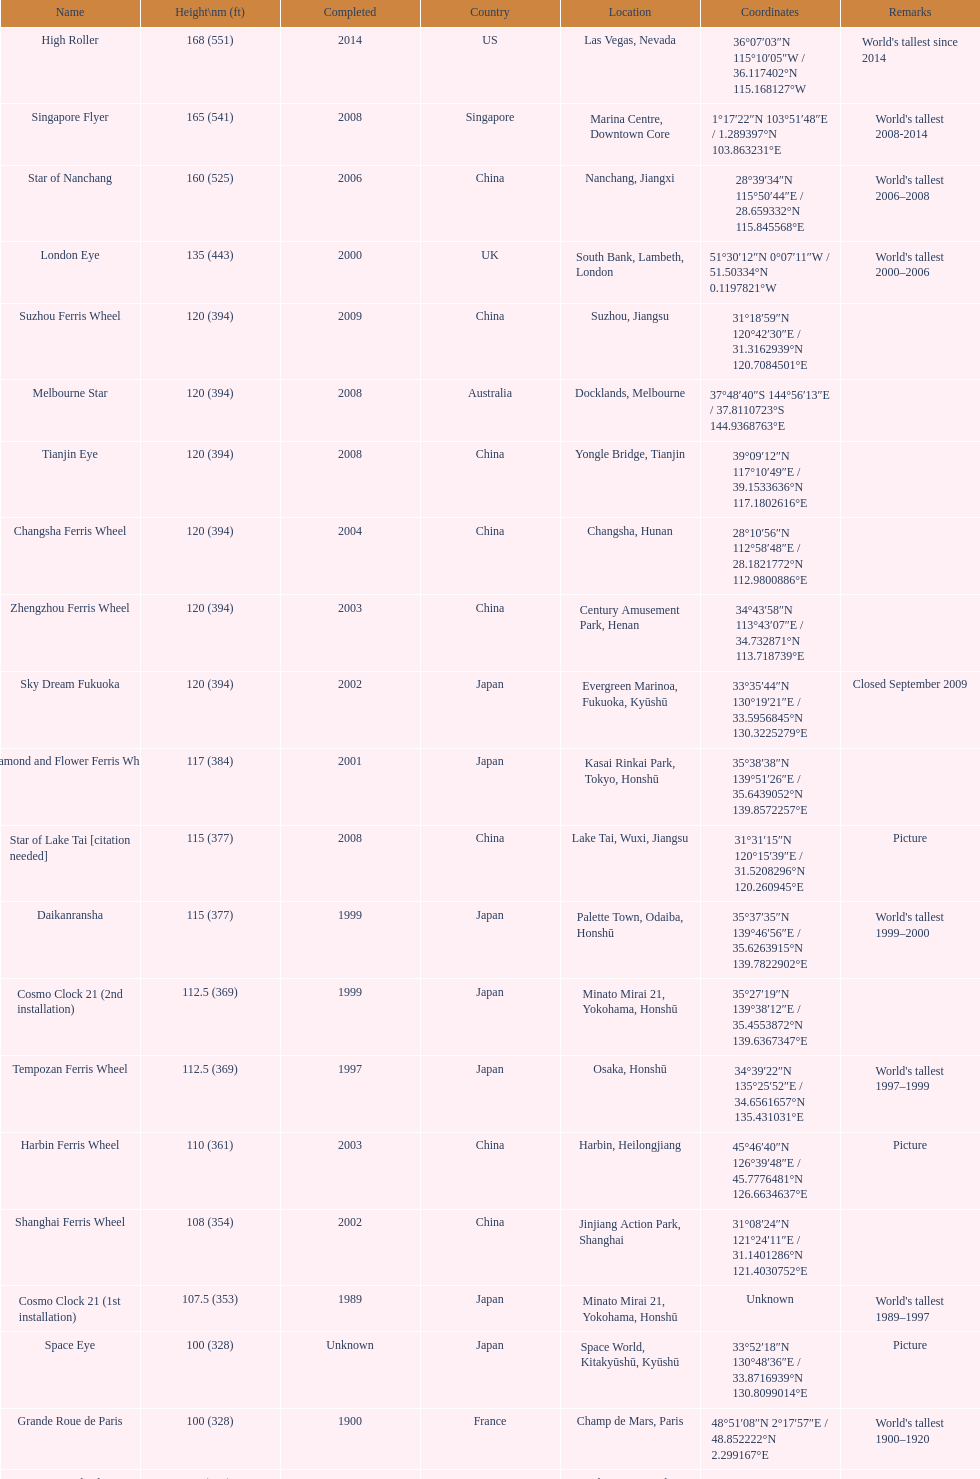In 2008, in which country were the most roller coasters with a height of over 80 feet located? China. 